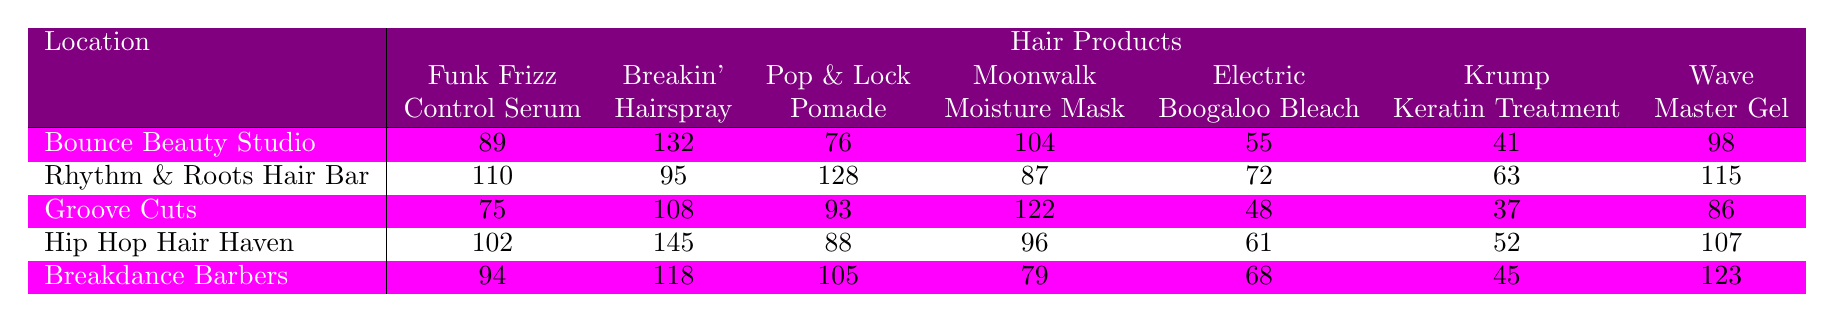What was the total sales of the "Wave Master Gel" across all salon locations? To find the total sales of the "Wave Master Gel," we need to add the following values from each location: 98 (Bounce Beauty Studio) + 115 (Rhythm & Roots Hair Bar) + 86 (Groove Cuts) + 107 (Hip Hop Hair Haven) + 123 (Breakdance Barbers) = 629.
Answer: 629 Which salon location had the highest sales of "Breakin' Hairspray"? By comparing the sales figures for "Breakin' Hairspray," we find 132 (Bounce Beauty Studio), 95 (Rhythm & Roots Hair Bar), 108 (Groove Cuts), 145 (Hip Hop Hair Haven), and 118 (Breakdance Barbers). The highest sales is 145 from Hip Hop Hair Haven.
Answer: Hip Hop Hair Haven Did "Electric Boogaloo Bleach" sell more than "Krump Keratin Treatment" in any salon? We compare sales: Bounce Beauty Studio (55 vs 41), Rhythm & Roots Hair Bar (72 vs 63), Groove Cuts (48 vs 37), Hip Hop Hair Haven (61 vs 52), and Breakdance Barbers (68 vs 45). In every case, "Electric Boogaloo Bleach" sold more than "Krump Keratin Treatment."
Answer: Yes What is the average sales of "Funk Frizz Control Serum" across all locations? The sales of "Funk Frizz Control Serum" are: 89 (Bounce Beauty Studio), 110 (Rhythm & Roots Hair Bar), 75 (Groove Cuts), 102 (Hip Hop Hair Haven), 94 (Breakdance Barbers). The sum is 470, and since there are 5 locations, the average is 470 / 5 = 94.
Answer: 94 Which product had the lowest sales in "Groove Cuts"? The sales figures for Groove Cuts are: Funk Frizz Control Serum (75), Breakin' Hairspray (108), Pop & Lock Pomade (93), Moonwalk Moisture Mask (122), Electric Boogaloo Bleach (48), Krump Keratin Treatment (37), Wave Master Gel (86). The lowest is 37 for "Krump Keratin Treatment."
Answer: Krump Keratin Treatment If we combine "Moonwalk Moisture Mask" sales from Bounce Beauty Studio and Breakdance Barbers, what would that total be? The sales for "Moonwalk Moisture Mask" are 104 (Bounce Beauty Studio) and 79 (Breakdance Barbers). Adding these together gives 104 + 79 = 183.
Answer: 183 Which salon has the highest overall sales when all products are summed? To determine this, we need to sum the sales for each salon: Bounce Beauty Studio (89 + 132 + 76 + 104 + 55 + 41 + 98 = 595), Rhythm & Roots Hair Bar (110 + 95 + 128 + 87 + 72 + 63 + 115 = 770), Groove Cuts (75 + 108 + 93 + 122 + 48 + 37 + 86 = 569), Hip Hop Hair Haven (102 + 145 + 88 + 96 + 61 + 52 + 107 = 651), and Breakdance Barbers (94 + 118 + 105 + 79 + 68 + 45 + 123 = 732). The highest total is 770 for Rhythm & Roots Hair Bar.
Answer: Rhythm & Roots Hair Bar What was the difference in sales between "Pop & Lock Pomade" at Hip Hop Hair Haven and Groove Cuts? Sales of "Pop & Lock Pomade" are 88 (Hip Hop Hair Haven) and 93 (Groove Cuts). The difference is 93 - 88 = 5.
Answer: 5 Which product sold the least in total when all locations are considered? The total sales for each product: Funk Frizz Control Serum (89 + 110 + 75 + 102 + 94 = 470), Breakin' Hairspray (132 + 95 + 108 + 145 + 118 = 698), Pop & Lock Pomade (76 + 128 + 93 + 88 + 105 = 490), Moonwalk Moisture Mask (104 + 87 + 122 + 96 + 79 = 488), Electric Boogaloo Bleach (55 + 72 + 48 + 61 + 68 = 304), Krump Keratin Treatment (41 + 63 + 37 + 52 + 45 = 238), Wave Master Gel (98 + 115 + 86 + 107 + 123 = 629). The product with the least sales is "Krump Keratin Treatment" with 238.
Answer: Krump Keratin Treatment 